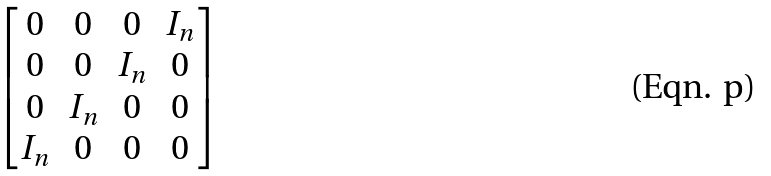Convert formula to latex. <formula><loc_0><loc_0><loc_500><loc_500>\begin{bmatrix} 0 & 0 & 0 & I _ { n } \\ 0 & 0 & I _ { n } & 0 \\ 0 & I _ { n } & 0 & 0 \\ I _ { n } & 0 & 0 & 0 \end{bmatrix}</formula> 